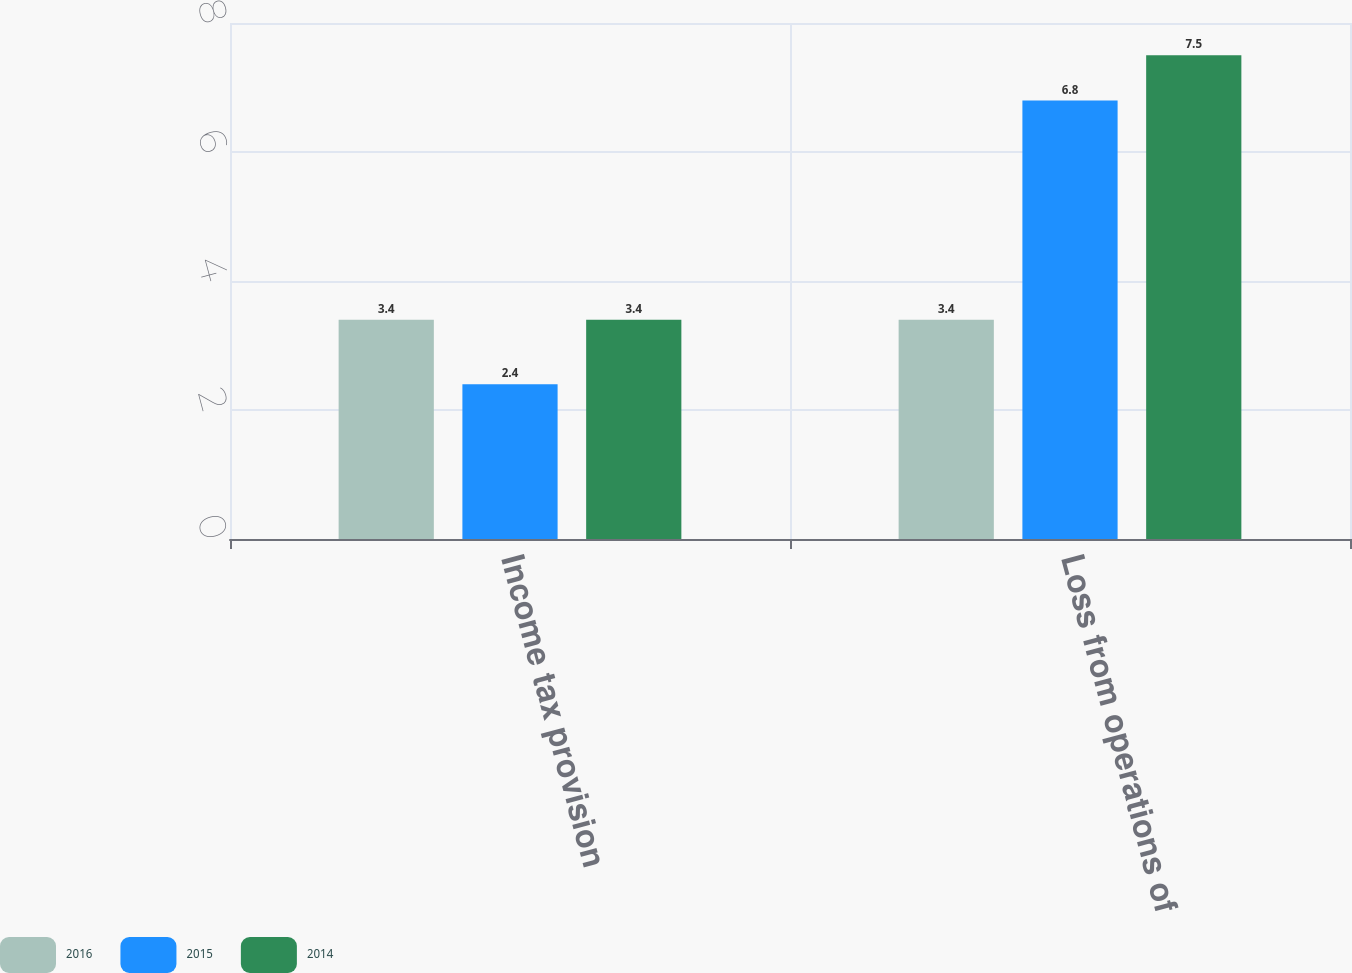Convert chart to OTSL. <chart><loc_0><loc_0><loc_500><loc_500><stacked_bar_chart><ecel><fcel>Income tax provision<fcel>Loss from operations of<nl><fcel>2016<fcel>3.4<fcel>3.4<nl><fcel>2015<fcel>2.4<fcel>6.8<nl><fcel>2014<fcel>3.4<fcel>7.5<nl></chart> 